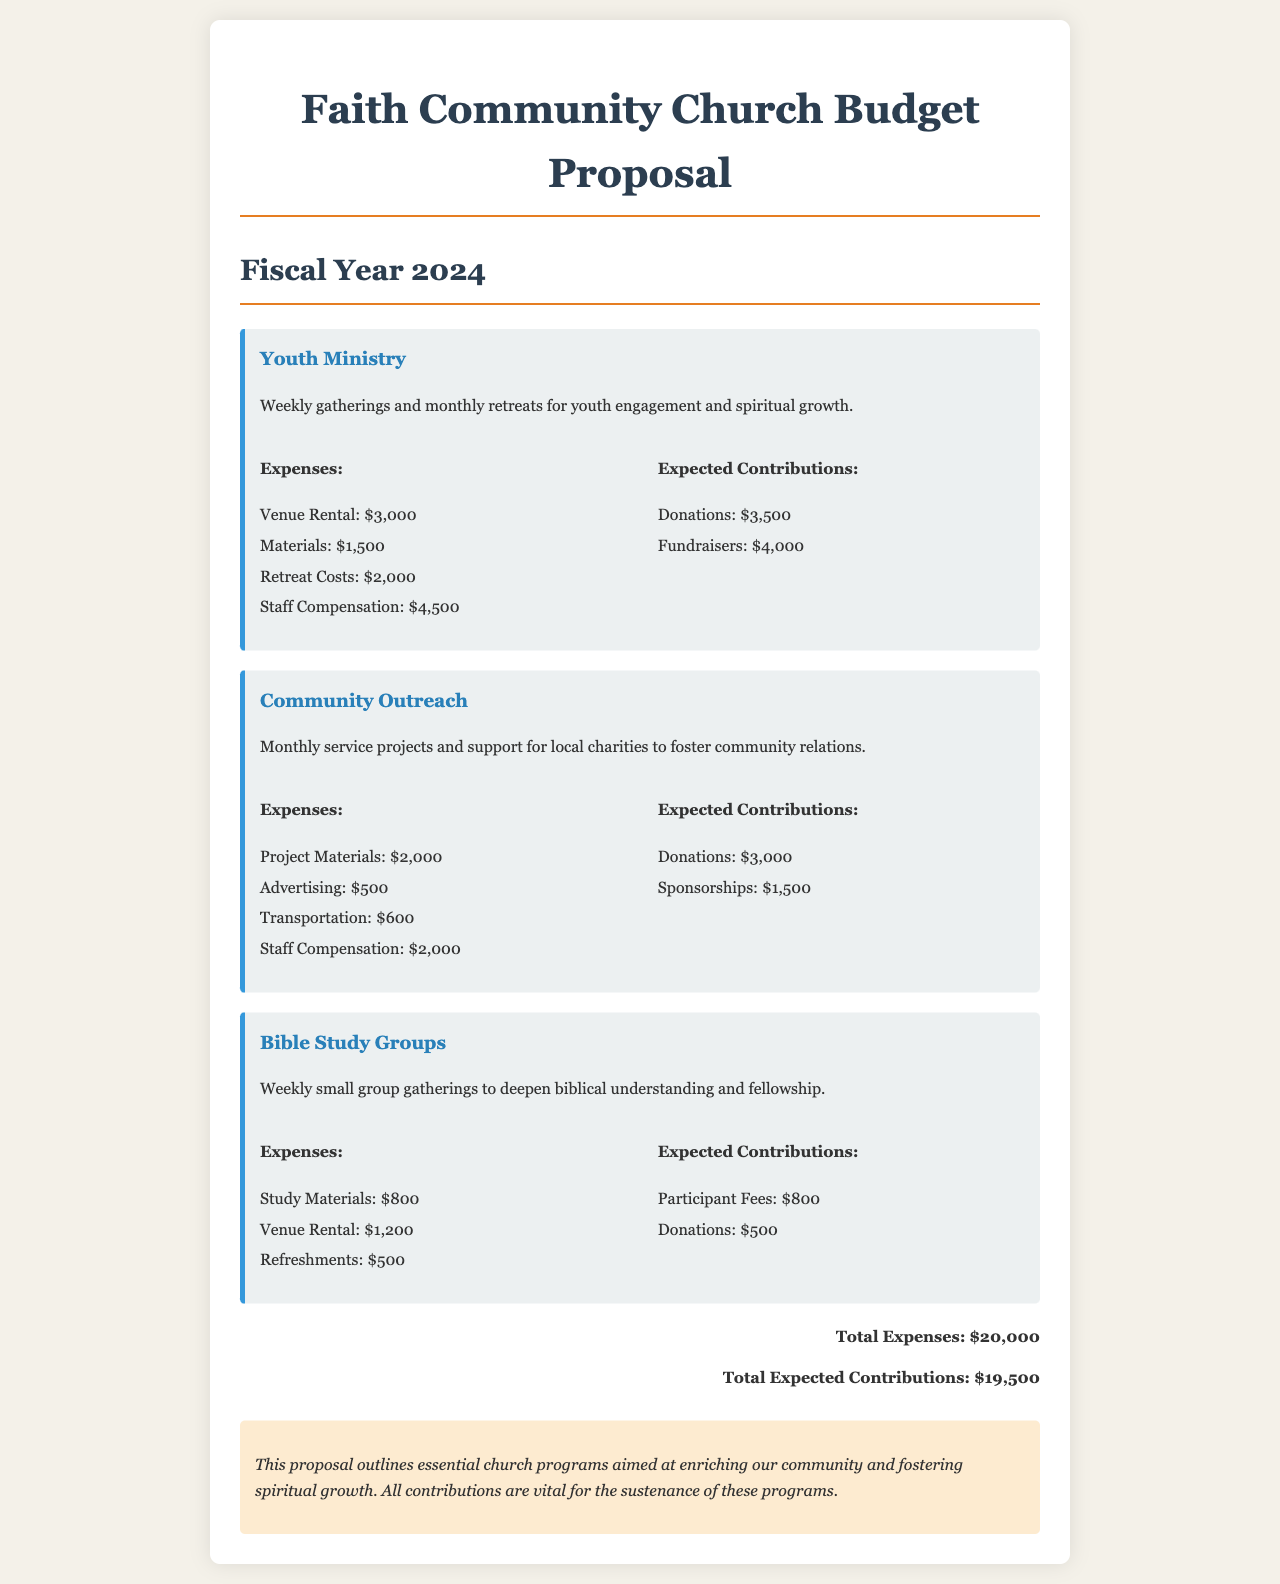What is the total budget for the Youth Ministry? The total expenses for the Youth Ministry are the sum of venue rental, materials, retreat costs, and staff compensation, which is $3,000 + $1,500 + $2,000 + $4,500 = $11,000.
Answer: $11,000 What are the expected donations for Community Outreach? The expected contributions for Community Outreach include donations which are stated as $3,000.
Answer: $3,000 How much will be spent on study materials for Bible Study Groups? The expenses for Bible Study Groups include study materials listed as $800.
Answer: $800 What is the total amount needed for all programs? The total expenses across all programs are $20,000 as indicated in the document.
Answer: $20,000 What is the total expected income? The total expected contributions for all programs sum up to $19,500 as noted in the document.
Answer: $19,500 What is the cost for staff compensation in the Youth Ministry? The document specifies staff compensation for the Youth Ministry is $4,500.
Answer: $4,500 Which program has the highest expenses? The Youth Ministry has the highest expenses totaling $11,000, as calculated from the stated expenses.
Answer: Youth Ministry What is the expense for project materials in Community Outreach? The document lists project materials for Community Outreach as $2,000.
Answer: $2,000 What percentage of the total budget does the expected contributions cover? The expected contributions of $19,500 cover 97.5% of the total budget of $20,000, calculated as (19,500/20,000) * 100.
Answer: 97.5% 